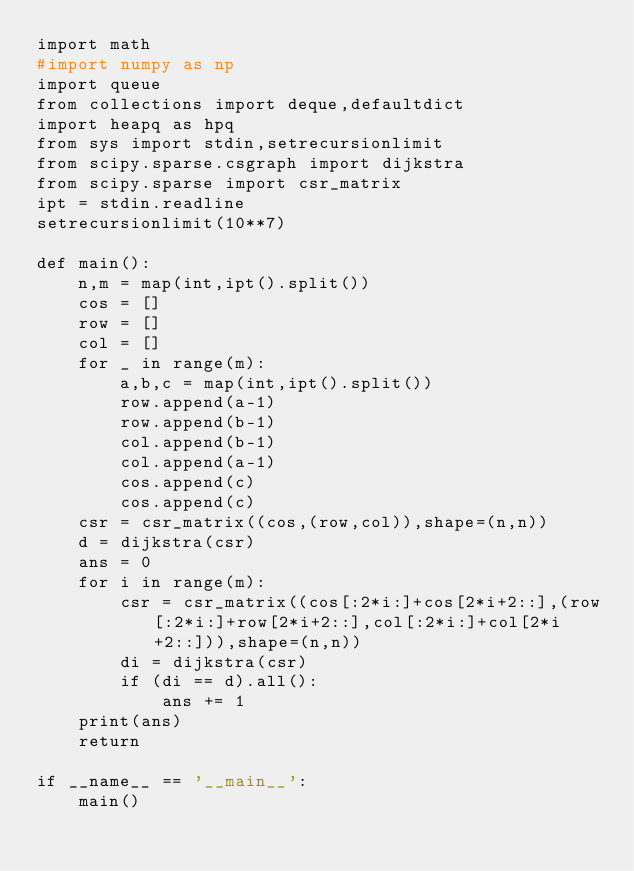Convert code to text. <code><loc_0><loc_0><loc_500><loc_500><_Python_>import math
#import numpy as np
import queue
from collections import deque,defaultdict
import heapq as hpq
from sys import stdin,setrecursionlimit
from scipy.sparse.csgraph import dijkstra
from scipy.sparse import csr_matrix
ipt = stdin.readline
setrecursionlimit(10**7)

def main():
    n,m = map(int,ipt().split())
    cos = []
    row = []
    col = []
    for _ in range(m):
        a,b,c = map(int,ipt().split())
        row.append(a-1)
        row.append(b-1)
        col.append(b-1)
        col.append(a-1)
        cos.append(c)
        cos.append(c)
    csr = csr_matrix((cos,(row,col)),shape=(n,n))
    d = dijkstra(csr)
    ans = 0
    for i in range(m):
        csr = csr_matrix((cos[:2*i:]+cos[2*i+2::],(row[:2*i:]+row[2*i+2::],col[:2*i:]+col[2*i+2::])),shape=(n,n))
        di = dijkstra(csr)
        if (di == d).all():
            ans += 1
    print(ans)
    return

if __name__ == '__main__':
    main()
</code> 